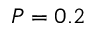Convert formula to latex. <formula><loc_0><loc_0><loc_500><loc_500>P = 0 . 2</formula> 